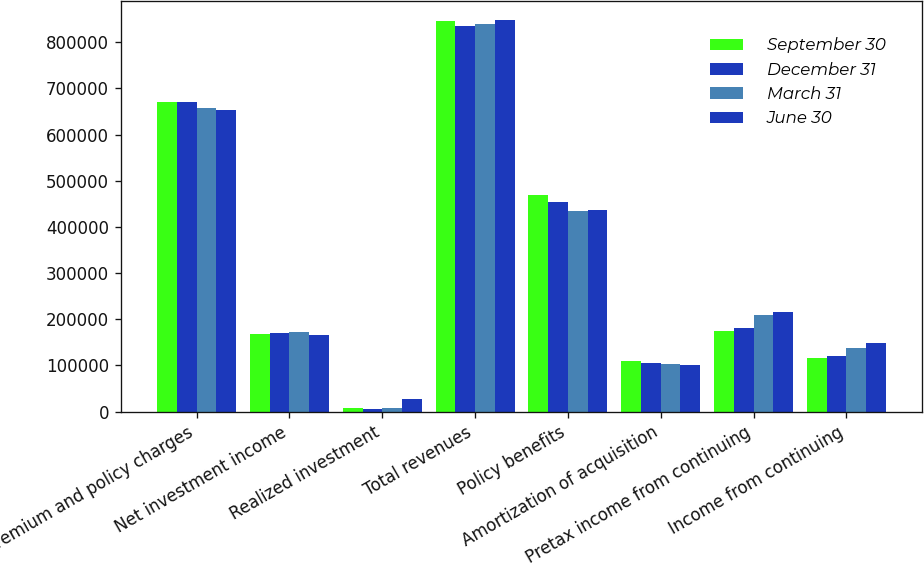<chart> <loc_0><loc_0><loc_500><loc_500><stacked_bar_chart><ecel><fcel>Premium and policy charges<fcel>Net investment income<fcel>Realized investment<fcel>Total revenues<fcel>Policy benefits<fcel>Amortization of acquisition<fcel>Pretax income from continuing<fcel>Income from continuing<nl><fcel>September 30<fcel>670944<fcel>167111<fcel>7261<fcel>845678<fcel>468934<fcel>109602<fcel>174054<fcel>115393<nl><fcel>December 31<fcel>669569<fcel>170612<fcel>5002<fcel>835895<fcel>454177<fcel>104851<fcel>180720<fcel>119848<nl><fcel>March 31<fcel>657827<fcel>172337<fcel>8045<fcel>838888<fcel>433514<fcel>104045<fcel>208313<fcel>138097<nl><fcel>June 30<fcel>653418<fcel>166304<fcel>27036<fcel>847171<fcel>436419<fcel>100392<fcel>215480<fcel>148955<nl></chart> 